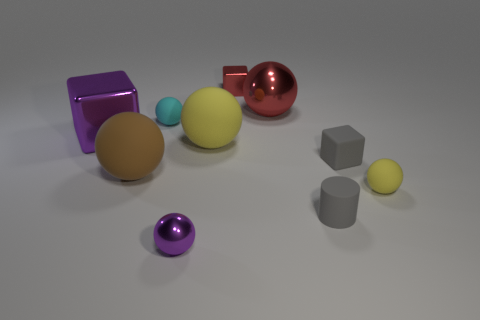Subtract all gray blocks. How many blocks are left? 2 Subtract all purple cubes. How many cubes are left? 2 Subtract all cubes. How many objects are left? 7 Add 7 cyan objects. How many cyan objects are left? 8 Add 7 green metallic things. How many green metallic things exist? 7 Subtract 0 green cylinders. How many objects are left? 10 Subtract 2 spheres. How many spheres are left? 4 Subtract all gray spheres. Subtract all red cylinders. How many spheres are left? 6 Subtract all green blocks. How many yellow spheres are left? 2 Subtract all big red things. Subtract all purple balls. How many objects are left? 8 